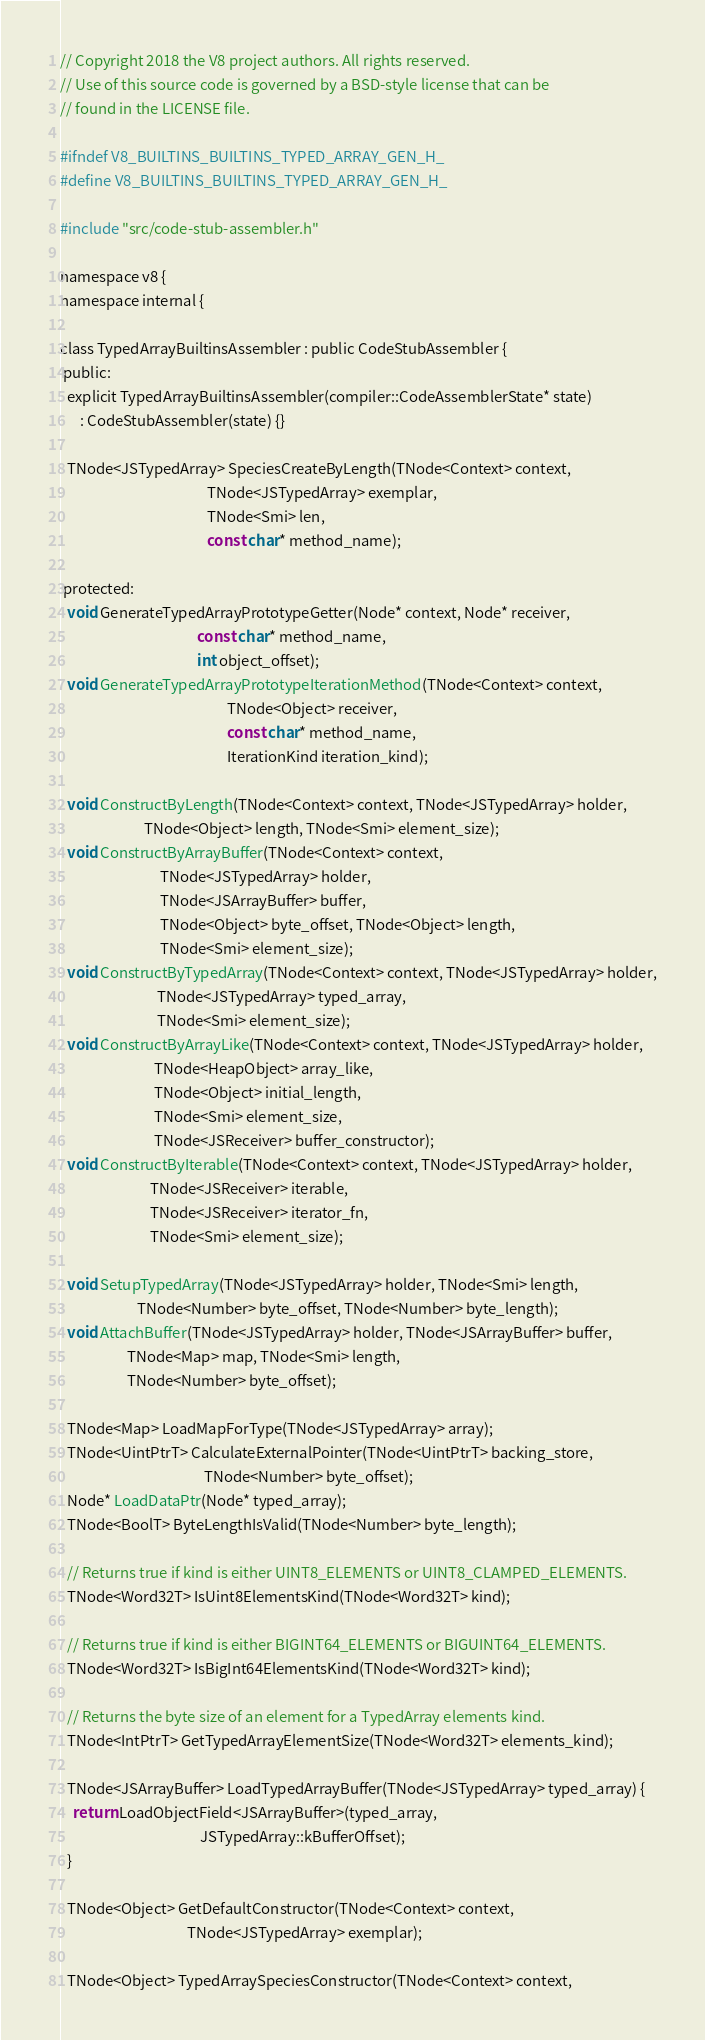Convert code to text. <code><loc_0><loc_0><loc_500><loc_500><_C_>// Copyright 2018 the V8 project authors. All rights reserved.
// Use of this source code is governed by a BSD-style license that can be
// found in the LICENSE file.

#ifndef V8_BUILTINS_BUILTINS_TYPED_ARRAY_GEN_H_
#define V8_BUILTINS_BUILTINS_TYPED_ARRAY_GEN_H_

#include "src/code-stub-assembler.h"

namespace v8 {
namespace internal {

class TypedArrayBuiltinsAssembler : public CodeStubAssembler {
 public:
  explicit TypedArrayBuiltinsAssembler(compiler::CodeAssemblerState* state)
      : CodeStubAssembler(state) {}

  TNode<JSTypedArray> SpeciesCreateByLength(TNode<Context> context,
                                            TNode<JSTypedArray> exemplar,
                                            TNode<Smi> len,
                                            const char* method_name);

 protected:
  void GenerateTypedArrayPrototypeGetter(Node* context, Node* receiver,
                                         const char* method_name,
                                         int object_offset);
  void GenerateTypedArrayPrototypeIterationMethod(TNode<Context> context,
                                                  TNode<Object> receiver,
                                                  const char* method_name,
                                                  IterationKind iteration_kind);

  void ConstructByLength(TNode<Context> context, TNode<JSTypedArray> holder,
                         TNode<Object> length, TNode<Smi> element_size);
  void ConstructByArrayBuffer(TNode<Context> context,
                              TNode<JSTypedArray> holder,
                              TNode<JSArrayBuffer> buffer,
                              TNode<Object> byte_offset, TNode<Object> length,
                              TNode<Smi> element_size);
  void ConstructByTypedArray(TNode<Context> context, TNode<JSTypedArray> holder,
                             TNode<JSTypedArray> typed_array,
                             TNode<Smi> element_size);
  void ConstructByArrayLike(TNode<Context> context, TNode<JSTypedArray> holder,
                            TNode<HeapObject> array_like,
                            TNode<Object> initial_length,
                            TNode<Smi> element_size,
                            TNode<JSReceiver> buffer_constructor);
  void ConstructByIterable(TNode<Context> context, TNode<JSTypedArray> holder,
                           TNode<JSReceiver> iterable,
                           TNode<JSReceiver> iterator_fn,
                           TNode<Smi> element_size);

  void SetupTypedArray(TNode<JSTypedArray> holder, TNode<Smi> length,
                       TNode<Number> byte_offset, TNode<Number> byte_length);
  void AttachBuffer(TNode<JSTypedArray> holder, TNode<JSArrayBuffer> buffer,
                    TNode<Map> map, TNode<Smi> length,
                    TNode<Number> byte_offset);

  TNode<Map> LoadMapForType(TNode<JSTypedArray> array);
  TNode<UintPtrT> CalculateExternalPointer(TNode<UintPtrT> backing_store,
                                           TNode<Number> byte_offset);
  Node* LoadDataPtr(Node* typed_array);
  TNode<BoolT> ByteLengthIsValid(TNode<Number> byte_length);

  // Returns true if kind is either UINT8_ELEMENTS or UINT8_CLAMPED_ELEMENTS.
  TNode<Word32T> IsUint8ElementsKind(TNode<Word32T> kind);

  // Returns true if kind is either BIGINT64_ELEMENTS or BIGUINT64_ELEMENTS.
  TNode<Word32T> IsBigInt64ElementsKind(TNode<Word32T> kind);

  // Returns the byte size of an element for a TypedArray elements kind.
  TNode<IntPtrT> GetTypedArrayElementSize(TNode<Word32T> elements_kind);

  TNode<JSArrayBuffer> LoadTypedArrayBuffer(TNode<JSTypedArray> typed_array) {
    return LoadObjectField<JSArrayBuffer>(typed_array,
                                          JSTypedArray::kBufferOffset);
  }

  TNode<Object> GetDefaultConstructor(TNode<Context> context,
                                      TNode<JSTypedArray> exemplar);

  TNode<Object> TypedArraySpeciesConstructor(TNode<Context> context,</code> 